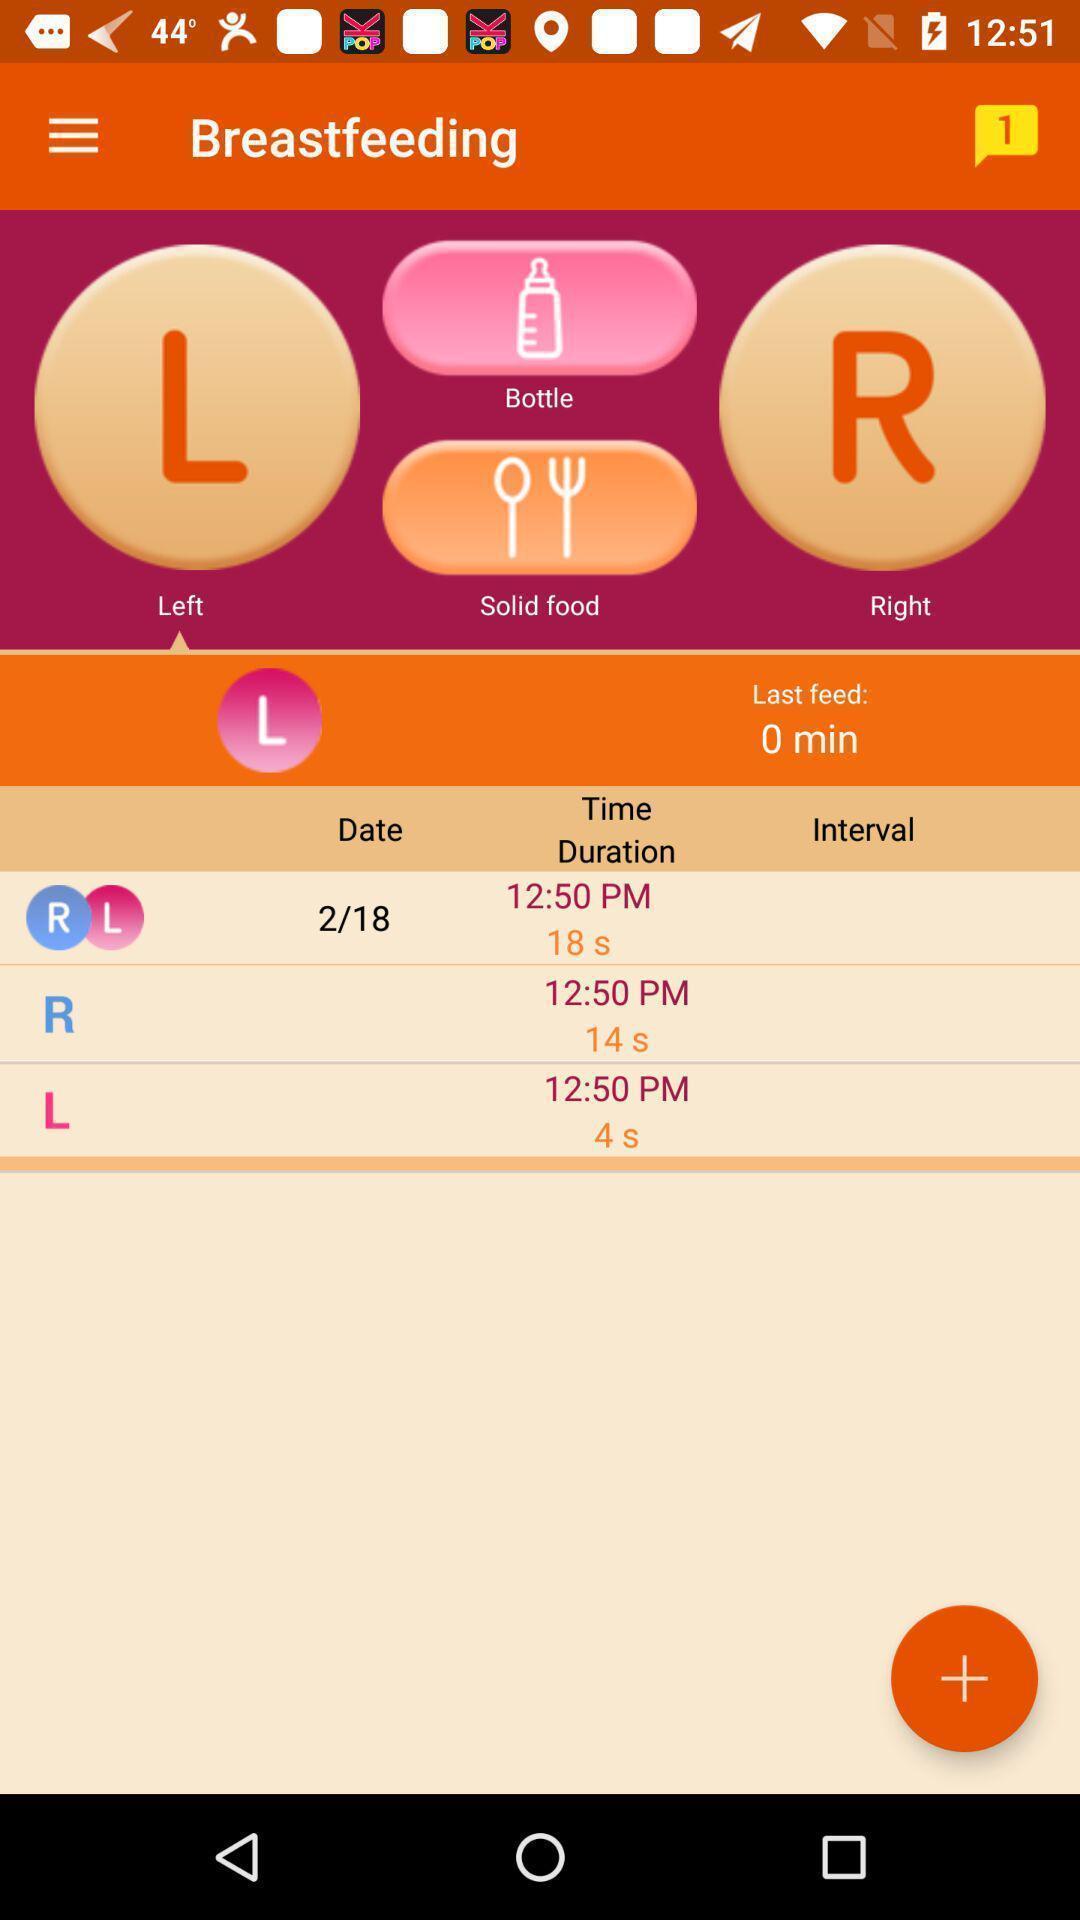Summarize the main components in this picture. Various details displayed of a health care hygiene app. 